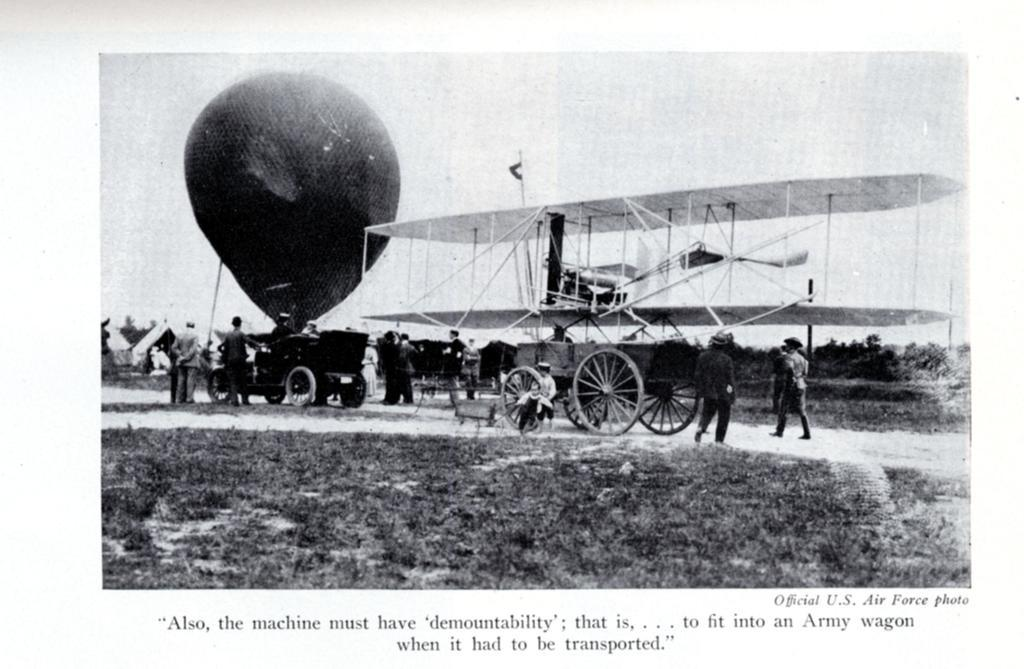What is the color scheme of the image? The image is black and white. What is the main subject of the image? There is an aeroplane in the image. What other objects can be seen in the image? There is a cart and a parachute in the image. Are there any people in the image? Yes, there are persons in the image. What can be seen in the background of the image? The sky is visible in the image. What type of pancake is being served on the cart in the image? There is no pancake present in the image; it features an aeroplane, a cart, a parachute, and persons. Can you see any oranges in the image? There are no oranges visible in the image. 